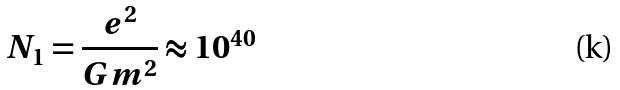<formula> <loc_0><loc_0><loc_500><loc_500>N _ { 1 } = \frac { e ^ { 2 } } { G m ^ { 2 } } \approx 1 0 ^ { 4 0 }</formula> 